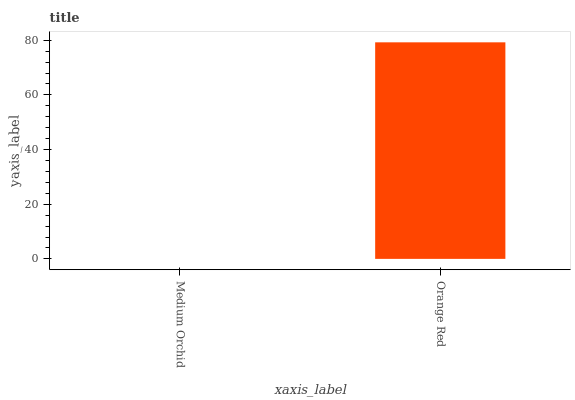Is Orange Red the minimum?
Answer yes or no. No. Is Orange Red greater than Medium Orchid?
Answer yes or no. Yes. Is Medium Orchid less than Orange Red?
Answer yes or no. Yes. Is Medium Orchid greater than Orange Red?
Answer yes or no. No. Is Orange Red less than Medium Orchid?
Answer yes or no. No. Is Orange Red the high median?
Answer yes or no. Yes. Is Medium Orchid the low median?
Answer yes or no. Yes. Is Medium Orchid the high median?
Answer yes or no. No. Is Orange Red the low median?
Answer yes or no. No. 